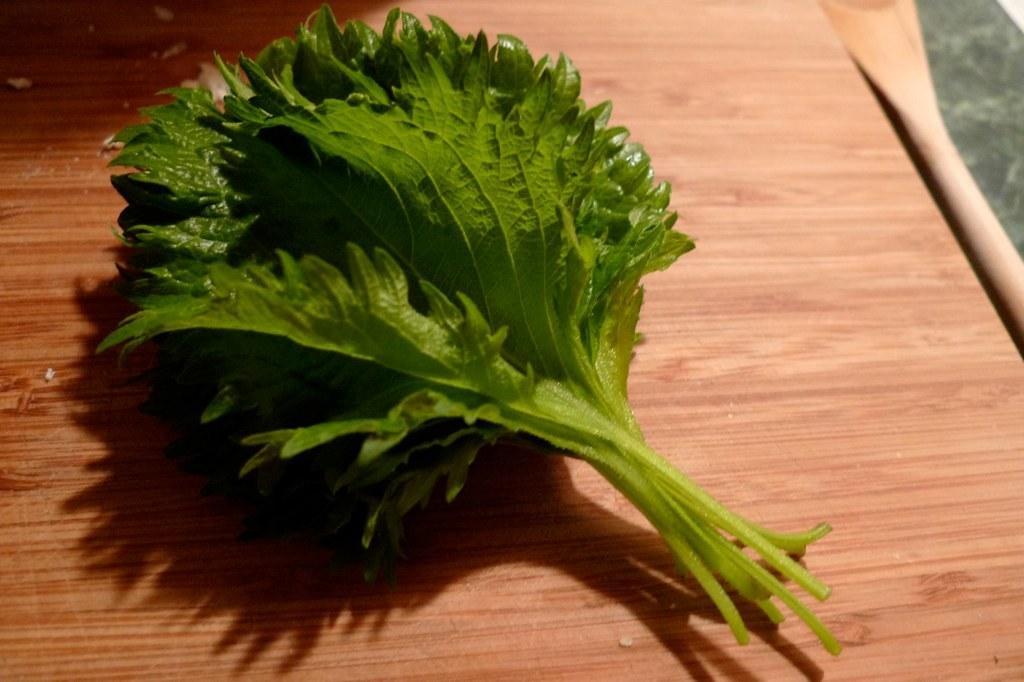What type of natural elements can be seen in the image? There are leaves in the image. Can you describe the leaves in the image? The leaves are likely from a tree or plant, and they may be green or have various colors depending on the season. What might be the purpose of including leaves in the image? The leaves could be used to create a natural or outdoor setting, or they might be part of a larger scene or composition. What type of iron is being polished in the image? There is no iron or polishing activity present in the image; it only contains leaves. 